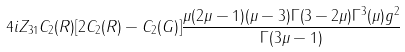<formula> <loc_0><loc_0><loc_500><loc_500>4 i Z _ { 3 1 } C _ { 2 } ( R ) [ 2 C _ { 2 } ( R ) - C _ { 2 } ( G ) ] \frac { \mu ( 2 \mu - 1 ) ( \mu - 3 ) \Gamma ( 3 - 2 \mu ) \Gamma ^ { 3 } ( \mu ) g ^ { 2 } } { \Gamma ( 3 \mu - 1 ) }</formula> 